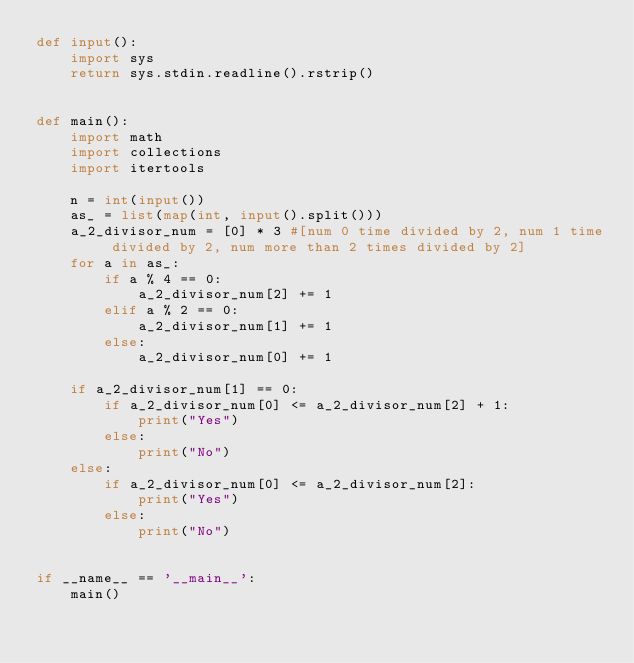<code> <loc_0><loc_0><loc_500><loc_500><_Python_>def input():
    import sys
    return sys.stdin.readline().rstrip()


def main():
    import math
    import collections
    import itertools

    n = int(input())
    as_ = list(map(int, input().split()))
    a_2_divisor_num = [0] * 3 #[num 0 time divided by 2, num 1 time divided by 2, num more than 2 times divided by 2]
    for a in as_:
        if a % 4 == 0:
            a_2_divisor_num[2] += 1
        elif a % 2 == 0:
            a_2_divisor_num[1] += 1
        else:
            a_2_divisor_num[0] += 1
    
    if a_2_divisor_num[1] == 0:
        if a_2_divisor_num[0] <= a_2_divisor_num[2] + 1:
            print("Yes")
        else:
            print("No")
    else:
        if a_2_divisor_num[0] <= a_2_divisor_num[2]:
            print("Yes")
        else:
            print("No")


if __name__ == '__main__':
    main()</code> 